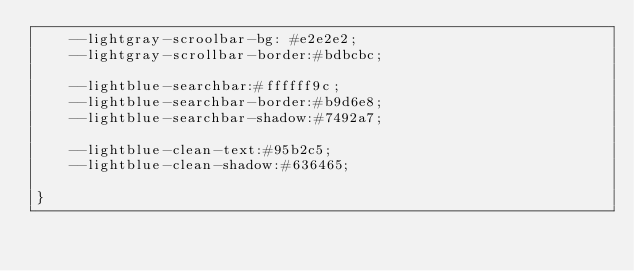<code> <loc_0><loc_0><loc_500><loc_500><_CSS_>    --lightgray-scroolbar-bg: #e2e2e2;
    --lightgray-scrollbar-border:#bdbcbc;

    --lightblue-searchbar:#ffffff9c;
    --lightblue-searchbar-border:#b9d6e8;
    --lightblue-searchbar-shadow:#7492a7;

    --lightblue-clean-text:#95b2c5;
    --lightblue-clean-shadow:#636465;
    
}</code> 